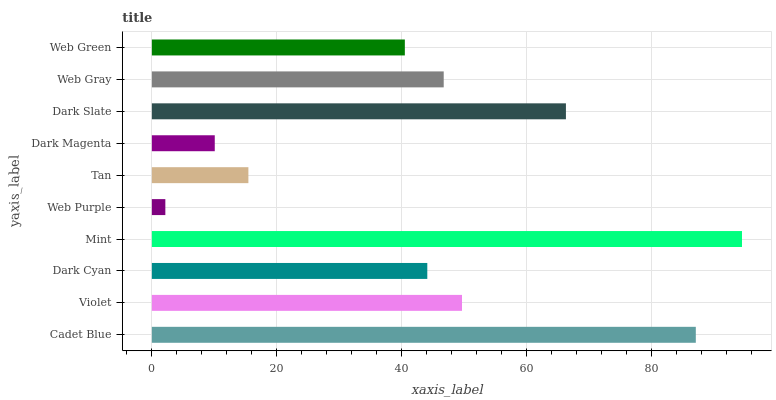Is Web Purple the minimum?
Answer yes or no. Yes. Is Mint the maximum?
Answer yes or no. Yes. Is Violet the minimum?
Answer yes or no. No. Is Violet the maximum?
Answer yes or no. No. Is Cadet Blue greater than Violet?
Answer yes or no. Yes. Is Violet less than Cadet Blue?
Answer yes or no. Yes. Is Violet greater than Cadet Blue?
Answer yes or no. No. Is Cadet Blue less than Violet?
Answer yes or no. No. Is Web Gray the high median?
Answer yes or no. Yes. Is Dark Cyan the low median?
Answer yes or no. Yes. Is Violet the high median?
Answer yes or no. No. Is Web Purple the low median?
Answer yes or no. No. 